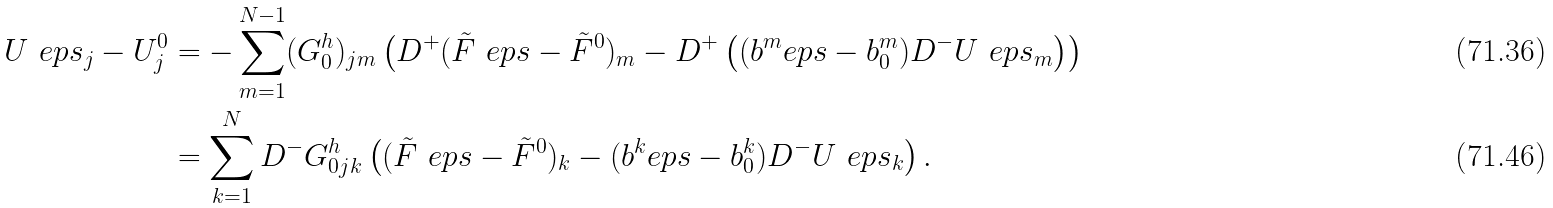<formula> <loc_0><loc_0><loc_500><loc_500>U ^ { \ } e p s _ { j } - U ^ { 0 } _ { j } & = - \sum _ { m = 1 } ^ { N - 1 } ( G ^ { h } _ { 0 } ) _ { j m } \left ( D ^ { + } ( \tilde { F } ^ { \ } e p s - \tilde { F } ^ { 0 } ) _ { m } - D ^ { + } \left ( ( b ^ { m } _ { \ } e p s - b ^ { m } _ { 0 } ) D ^ { - } U ^ { \ } e p s _ { m } \right ) \right ) \\ & = \sum _ { k = 1 } ^ { N } D ^ { - } G ^ { h } _ { 0 j k } \left ( ( \tilde { F } ^ { \ } e p s - \tilde { F } ^ { 0 } ) _ { k } - ( b ^ { k } _ { \ } e p s - b ^ { k } _ { 0 } ) D ^ { - } U ^ { \ } e p s _ { k } \right ) .</formula> 